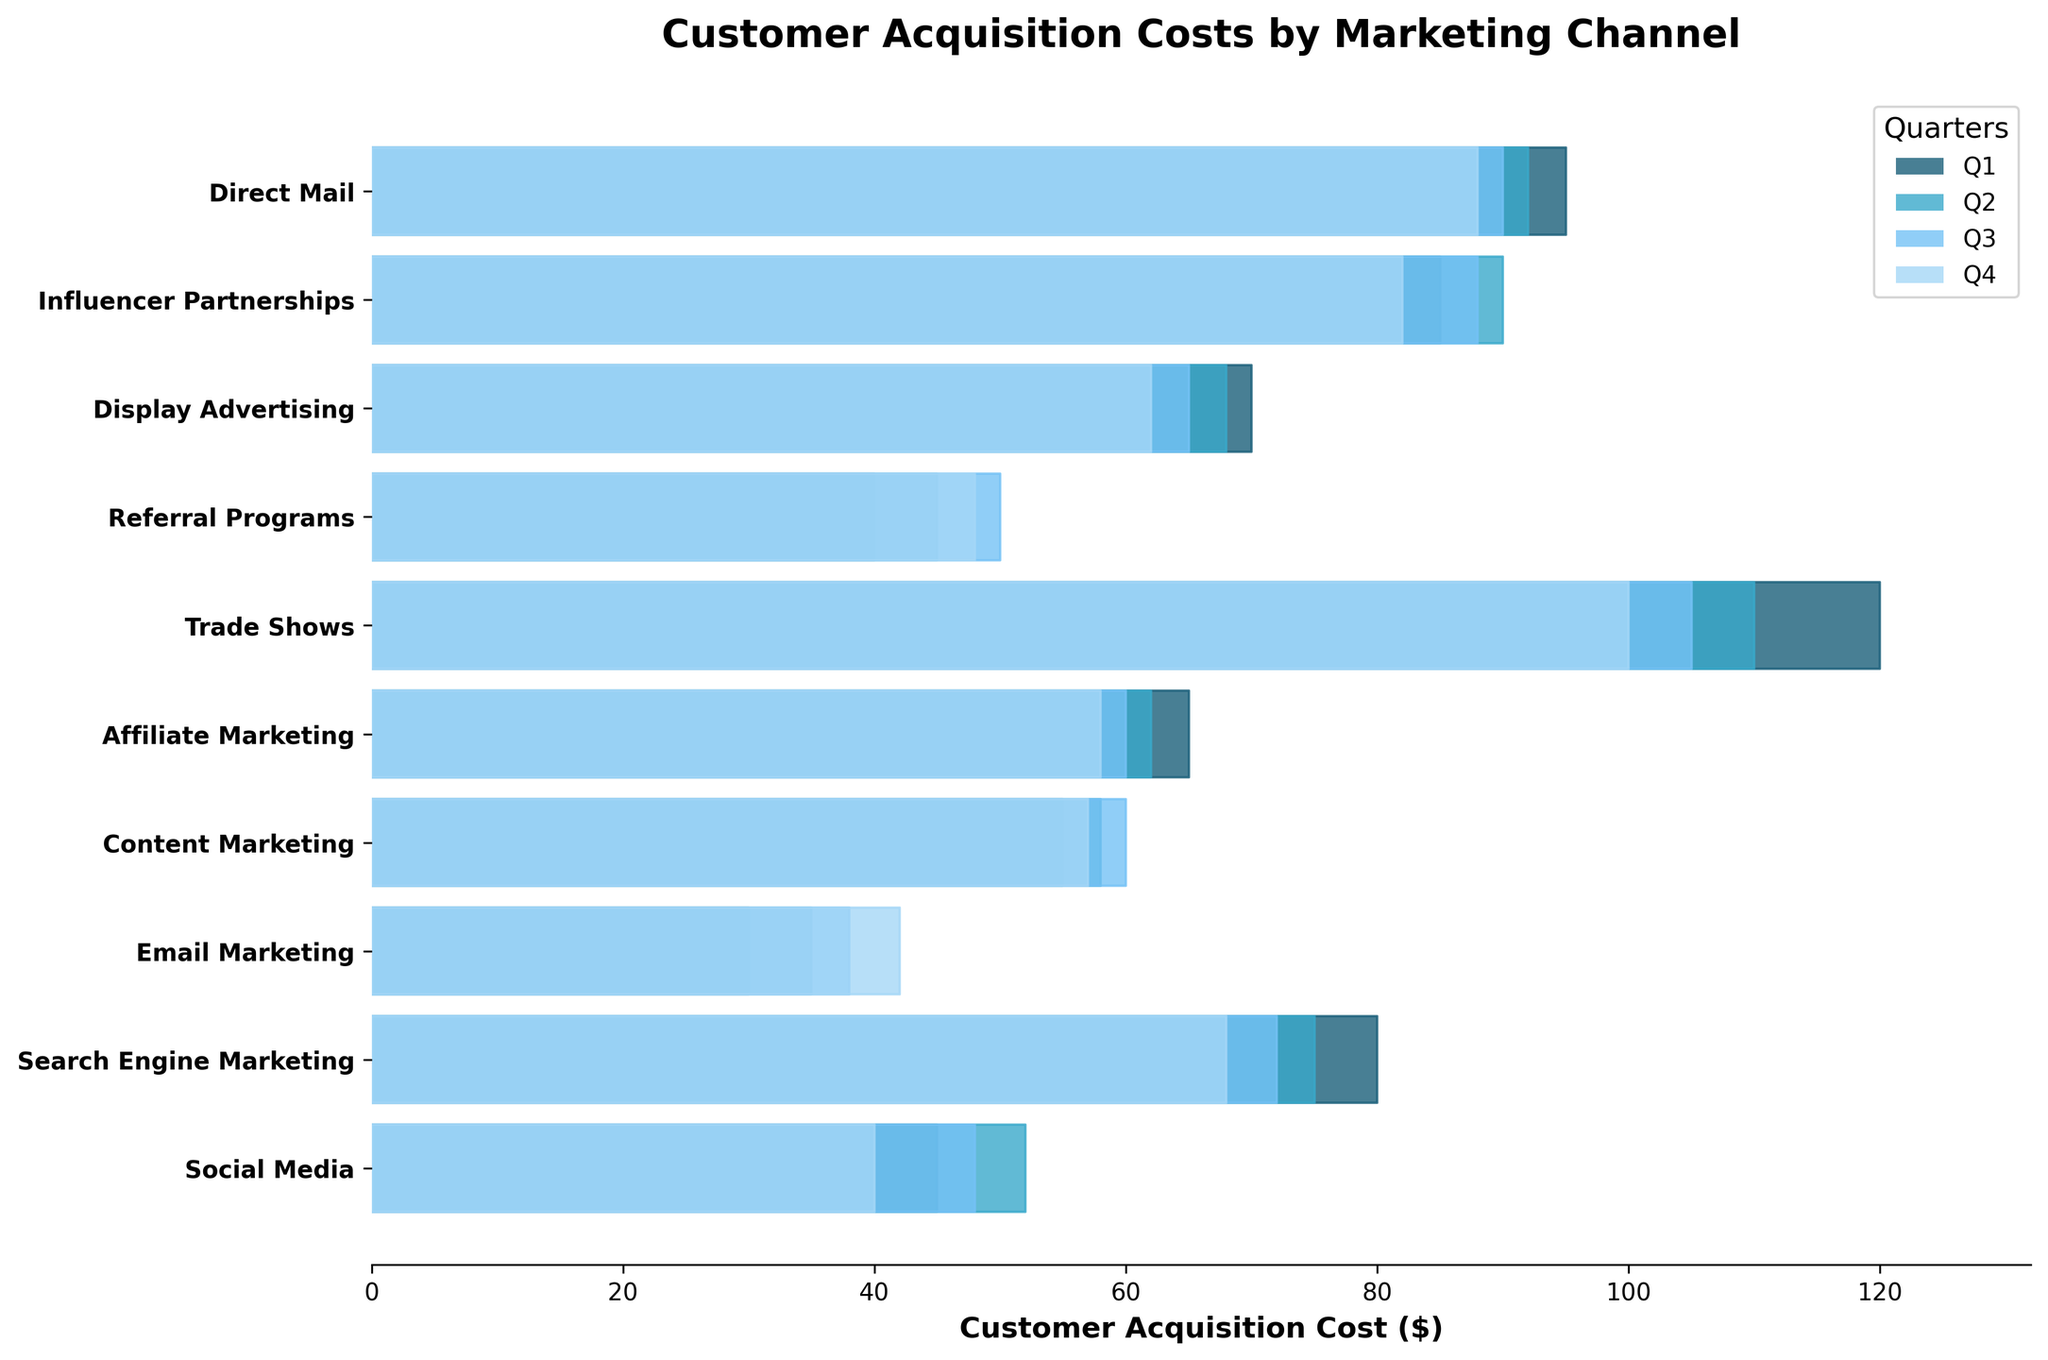What is the title of the figure? The title is usually found at the top of the figure, summarizing what the figure is about. In this case, it's directly indicated in the `ax.set_title` method of the code.
Answer: Customer Acquisition Costs by Marketing Channel How many marketing channels are represented in the plot? Each marketing channel is a separate category plotted along the y-axis. You can count the number of unique channel names along this axis.
Answer: 10 Which quarter has the highest acquisition cost for Social Media? Look at the section of the plot for Social Media and identify which quarter has the longest bar, indicating the highest acquisition cost.
Answer: Q2 What is the customer acquisition cost for Trade Shows in Q2? Find the Trade Shows channel and then look at the length of the section colored according to Q2 in the Ridgeline plot. The x-axis label will indicate the cost.
Answer: 110 Which marketing channel shows the largest decrease in customer acquisition cost from Q1 to Q4? Compare the length of the bars from Q1 to Q4 for each marketing channel and identify the one with the biggest reduction.
Answer: Trade Shows What is the average customer acquisition cost for Email Marketing across all quarters? Add up the acquisition costs for Email Marketing in Q1, Q2, Q3, and Q4, then divide by 4. (30 + 35 + 38 + 42) / 4 = 145 / 4
Answer: 36.25 How does the acquisition cost trend for Influencer Partnerships change from Q1 to Q4? Look at the bars for Influencer Partnerships in the plot and describe the general trend in their lengths from Q1 to Q4.
Answer: It increases from Q1 to Q2, then decreases through Q4 Which quarter had the highest overall customer acquisition cost on average across all marketing channels? Calculate the average acquisition cost for each quarter by summing the costs for all channels in each quarter and dividing by the number of channels. Compare these averages.
Answer: Q1 What is the difference in customer acquisition cost between Direct Mail and Display Advertising in Q4? Subtract the Q4 value for Display Advertising from the Q4 value for Direct Mail, based on the lengths of the corresponding bars. 88 - 62 = 26
Answer: 26 Which marketing channel has the most consistent customer acquisition costs over all four quarters? Identify the marketing channel where the lengths of the bars for each quarter are most similar.
Answer: Affiliate Marketing 